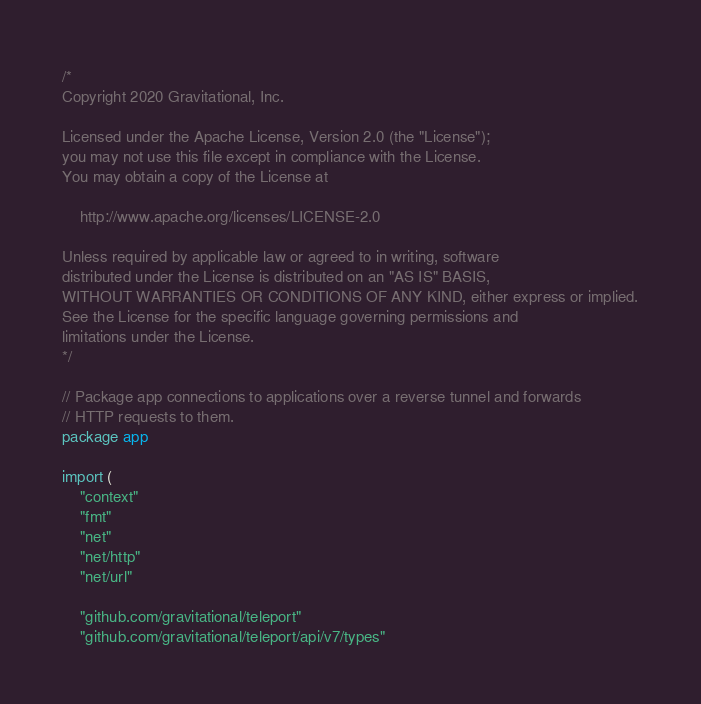<code> <loc_0><loc_0><loc_500><loc_500><_Go_>/*
Copyright 2020 Gravitational, Inc.

Licensed under the Apache License, Version 2.0 (the "License");
you may not use this file except in compliance with the License.
You may obtain a copy of the License at

    http://www.apache.org/licenses/LICENSE-2.0

Unless required by applicable law or agreed to in writing, software
distributed under the License is distributed on an "AS IS" BASIS,
WITHOUT WARRANTIES OR CONDITIONS OF ANY KIND, either express or implied.
See the License for the specific language governing permissions and
limitations under the License.
*/

// Package app connections to applications over a reverse tunnel and forwards
// HTTP requests to them.
package app

import (
	"context"
	"fmt"
	"net"
	"net/http"
	"net/url"

	"github.com/gravitational/teleport"
	"github.com/gravitational/teleport/api/v7/types"</code> 